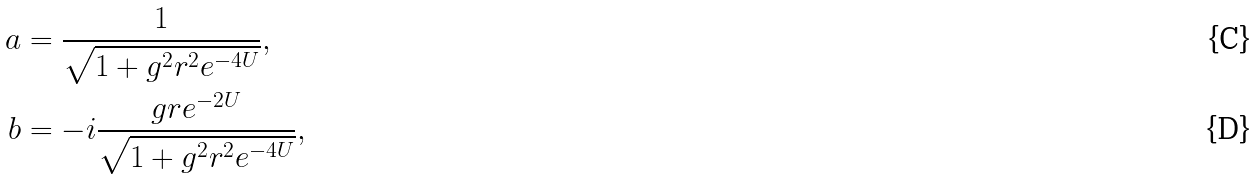<formula> <loc_0><loc_0><loc_500><loc_500>a & = { \frac { 1 } { \sqrt { 1 + g ^ { 2 } r ^ { 2 } e ^ { - 4 U } } } } , \\ b & = - { i \frac { g r e ^ { - 2 U } } { \sqrt { 1 + g ^ { 2 } r ^ { 2 } e ^ { - 4 U } } } } ,</formula> 